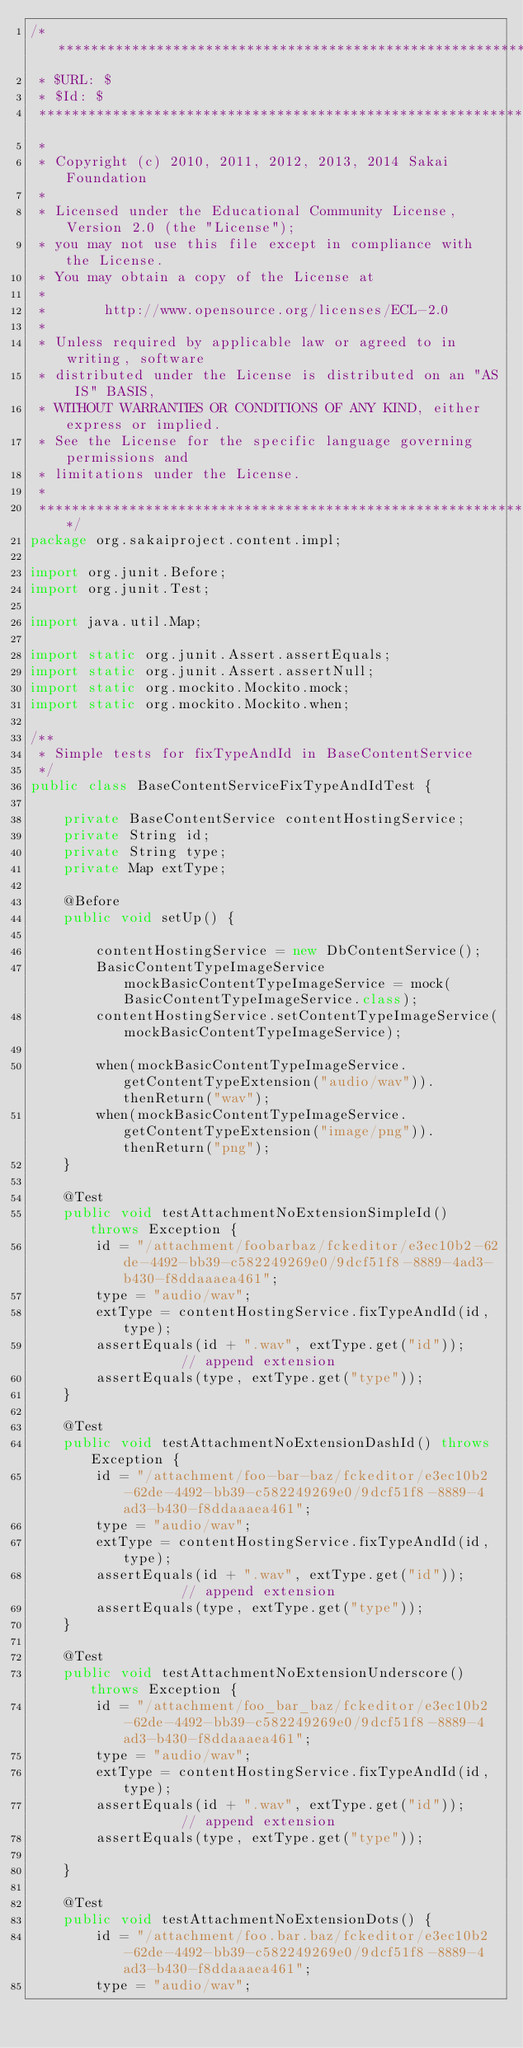<code> <loc_0><loc_0><loc_500><loc_500><_Java_>/**********************************************************************************
 * $URL: $
 * $Id: $
 ***********************************************************************************
 *
 * Copyright (c) 2010, 2011, 2012, 2013, 2014 Sakai Foundation
 *
 * Licensed under the Educational Community License, Version 2.0 (the "License");
 * you may not use this file except in compliance with the License.
 * You may obtain a copy of the License at
 *
 *       http://www.opensource.org/licenses/ECL-2.0
 *
 * Unless required by applicable law or agreed to in writing, software
 * distributed under the License is distributed on an "AS IS" BASIS,
 * WITHOUT WARRANTIES OR CONDITIONS OF ANY KIND, either express or implied.
 * See the License for the specific language governing permissions and
 * limitations under the License.
 *
 **********************************************************************************/
package org.sakaiproject.content.impl;

import org.junit.Before;
import org.junit.Test;

import java.util.Map;

import static org.junit.Assert.assertEquals;
import static org.junit.Assert.assertNull;
import static org.mockito.Mockito.mock;
import static org.mockito.Mockito.when;

/**
 * Simple tests for fixTypeAndId in BaseContentService
 */
public class BaseContentServiceFixTypeAndIdTest {

    private BaseContentService contentHostingService;
    private String id;
    private String type;
    private Map extType;

    @Before
    public void setUp() {

        contentHostingService = new DbContentService();
        BasicContentTypeImageService mockBasicContentTypeImageService = mock(BasicContentTypeImageService.class);
        contentHostingService.setContentTypeImageService(mockBasicContentTypeImageService);

        when(mockBasicContentTypeImageService.getContentTypeExtension("audio/wav")).thenReturn("wav");
        when(mockBasicContentTypeImageService.getContentTypeExtension("image/png")).thenReturn("png");
    }

    @Test
    public void testAttachmentNoExtensionSimpleId() throws Exception {
        id = "/attachment/foobarbaz/fckeditor/e3ec10b2-62de-4492-bb39-c582249269e0/9dcf51f8-8889-4ad3-b430-f8ddaaaea461";
        type = "audio/wav";
        extType = contentHostingService.fixTypeAndId(id, type);
        assertEquals(id + ".wav", extType.get("id"));        // append extension
        assertEquals(type, extType.get("type"));
    }

    @Test
    public void testAttachmentNoExtensionDashId() throws Exception {
        id = "/attachment/foo-bar-baz/fckeditor/e3ec10b2-62de-4492-bb39-c582249269e0/9dcf51f8-8889-4ad3-b430-f8ddaaaea461";
        type = "audio/wav";
        extType = contentHostingService.fixTypeAndId(id, type);
        assertEquals(id + ".wav", extType.get("id"));        // append extension
        assertEquals(type, extType.get("type"));
    }

    @Test
    public void testAttachmentNoExtensionUnderscore() throws Exception {
        id = "/attachment/foo_bar_baz/fckeditor/e3ec10b2-62de-4492-bb39-c582249269e0/9dcf51f8-8889-4ad3-b430-f8ddaaaea461";
        type = "audio/wav";
        extType = contentHostingService.fixTypeAndId(id, type);
        assertEquals(id + ".wav", extType.get("id"));        // append extension
        assertEquals(type, extType.get("type"));

    }

    @Test
    public void testAttachmentNoExtensionDots() {
        id = "/attachment/foo.bar.baz/fckeditor/e3ec10b2-62de-4492-bb39-c582249269e0/9dcf51f8-8889-4ad3-b430-f8ddaaaea461";
        type = "audio/wav";</code> 